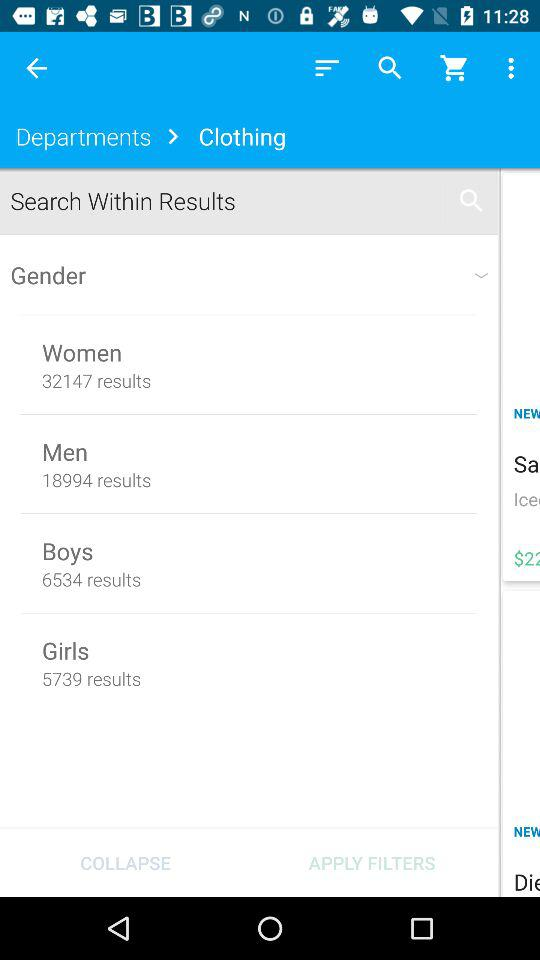How many more results are there for Women than for Men?
Answer the question using a single word or phrase. 13153 